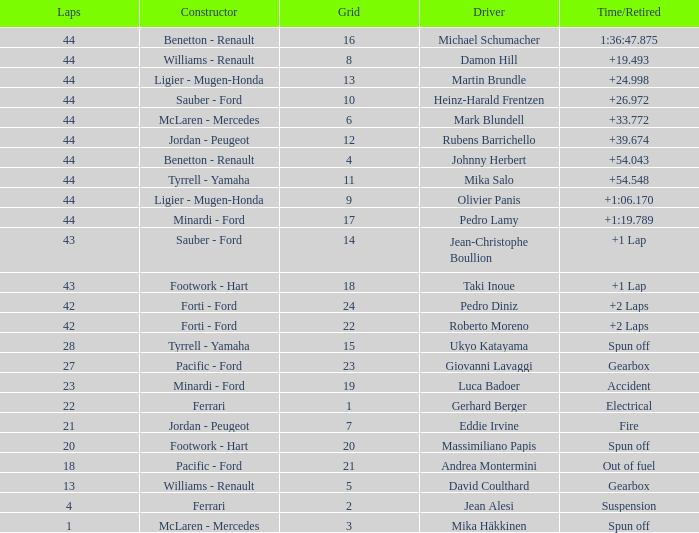What is the high lap total for cards with a grid larger than 21, and a Time/Retired of +2 laps? 42.0. 